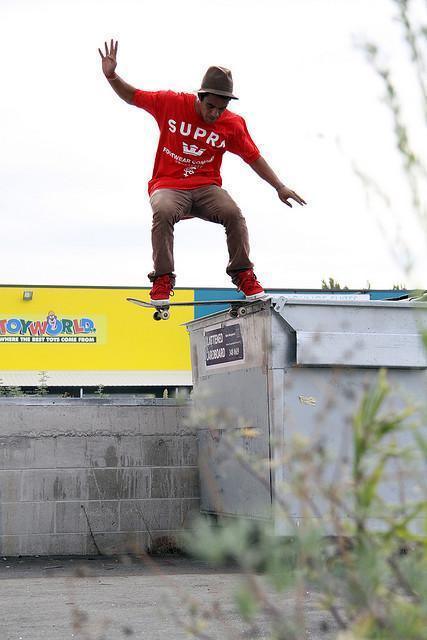How many giraffes are there?
Give a very brief answer. 0. 